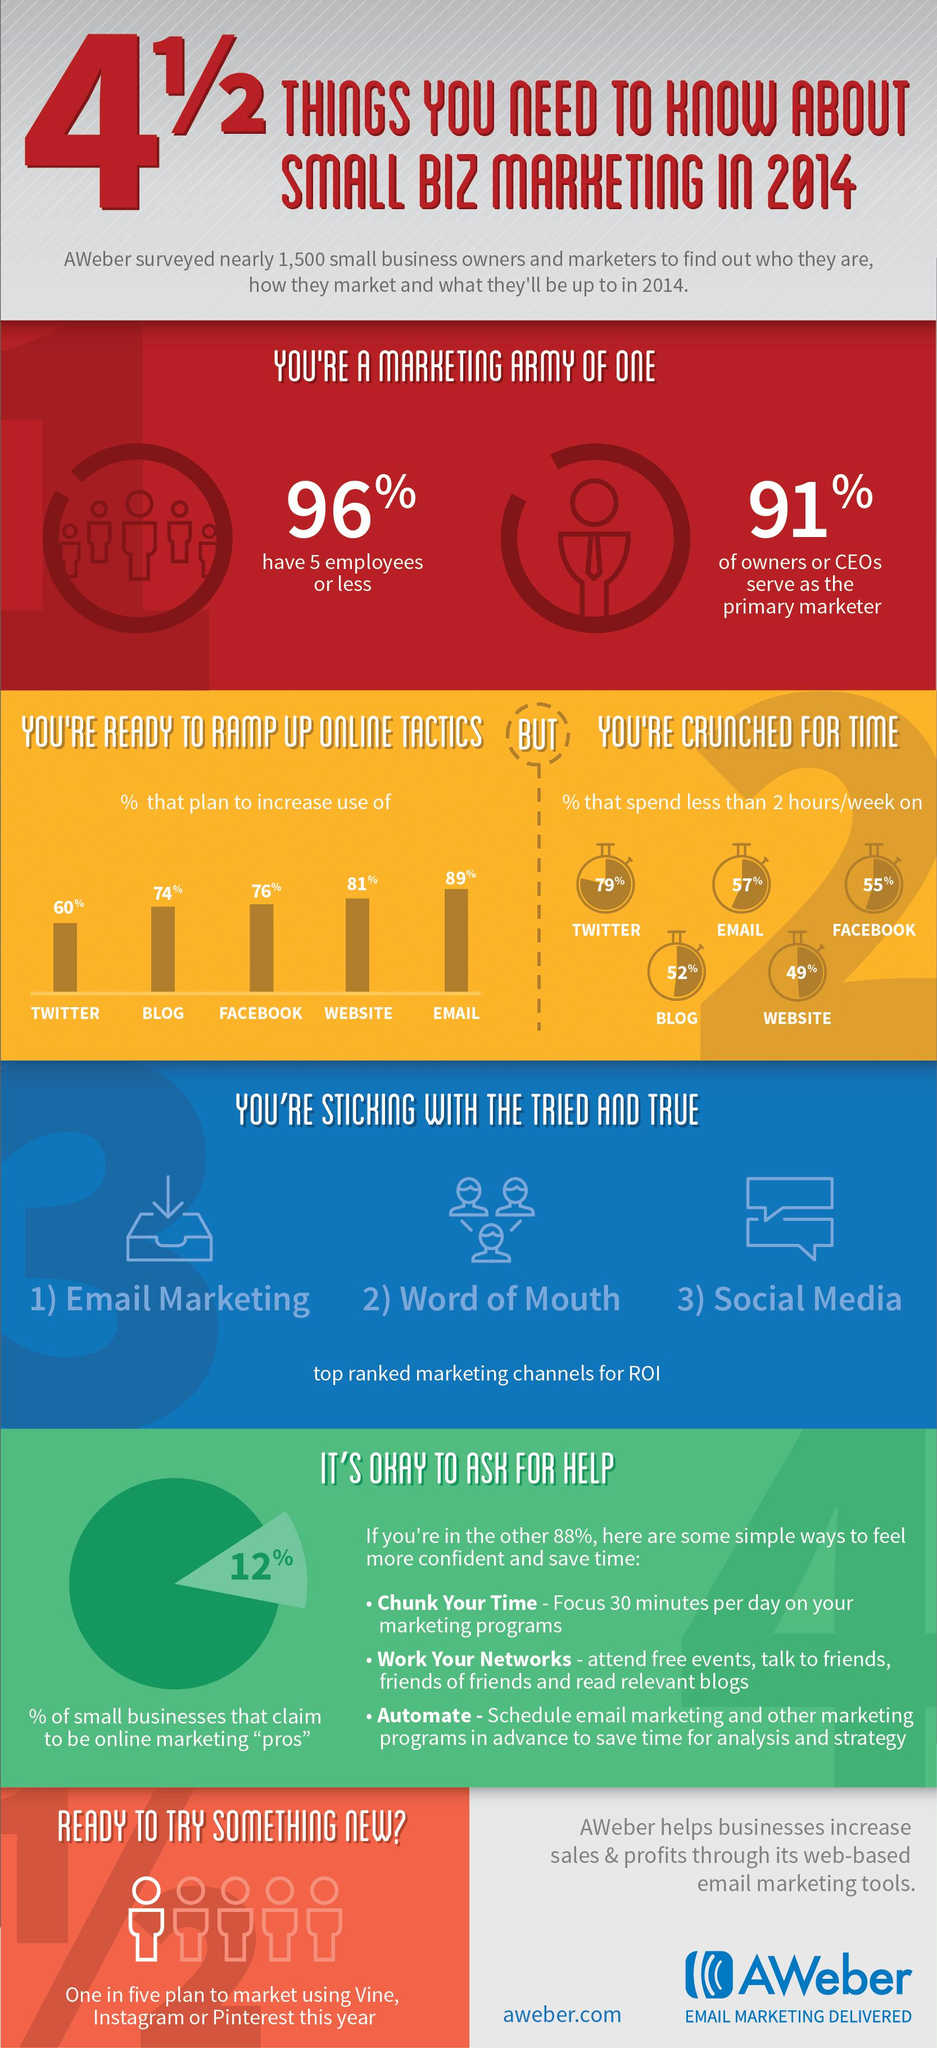Specify some key components in this picture. According to the survey, 57% of respondents reported spending less than 2 hours per week on emails in 2014. According to a survey, 60% of small business owners and marketers plan to increase the use of Twitter as a part of their online marketing tactics in 2014. According to a survey conducted in 2014, 52% of respondents reported spending less than 2 hours per week on blogs. Seventy-six percent of small business owners and marketers plan to increase their use of Facebook as a part of their online marketing tactics in 2014. Eighty-one percent of small business owners and marketers plan to increase the use of websites as a part of their online marketing tactics in 2014. 